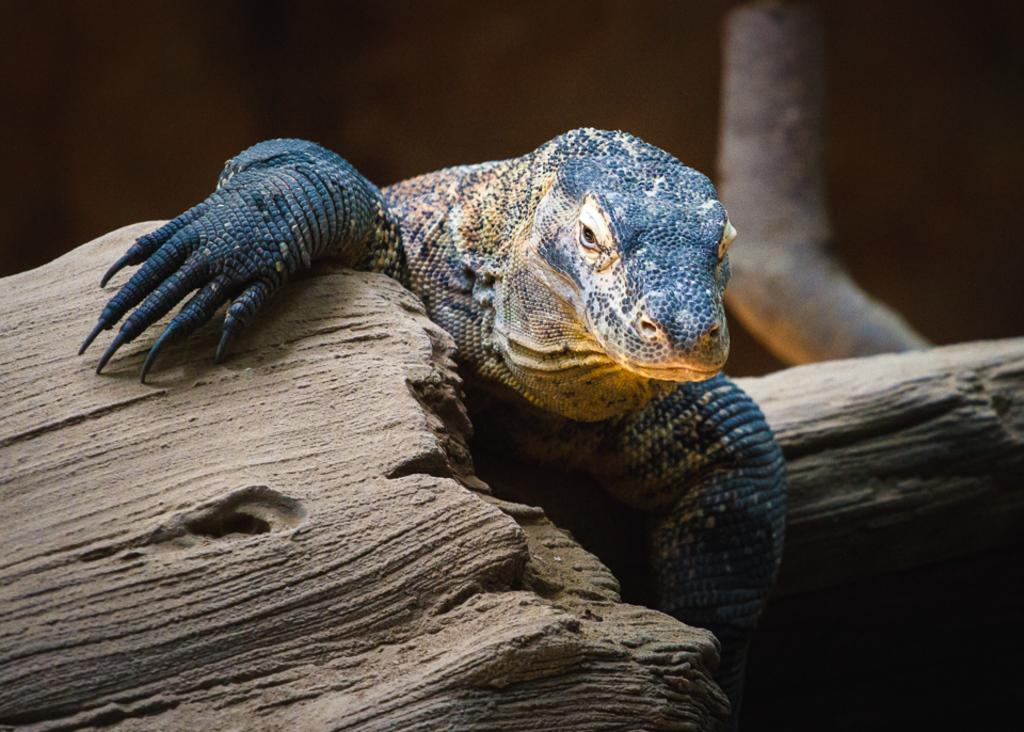What type of creature is present in the image? There is an animal in the image. Can you describe the color of the animal? The animal is black in color. What is the value of the grandmother's ticket in the image? There is no grandmother or ticket present in the image. 